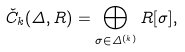Convert formula to latex. <formula><loc_0><loc_0><loc_500><loc_500>\check { C } _ { k } ( \Delta , R ) = \bigoplus _ { \sigma \in \Delta ^ { ( k ) } } R [ \sigma ] ,</formula> 